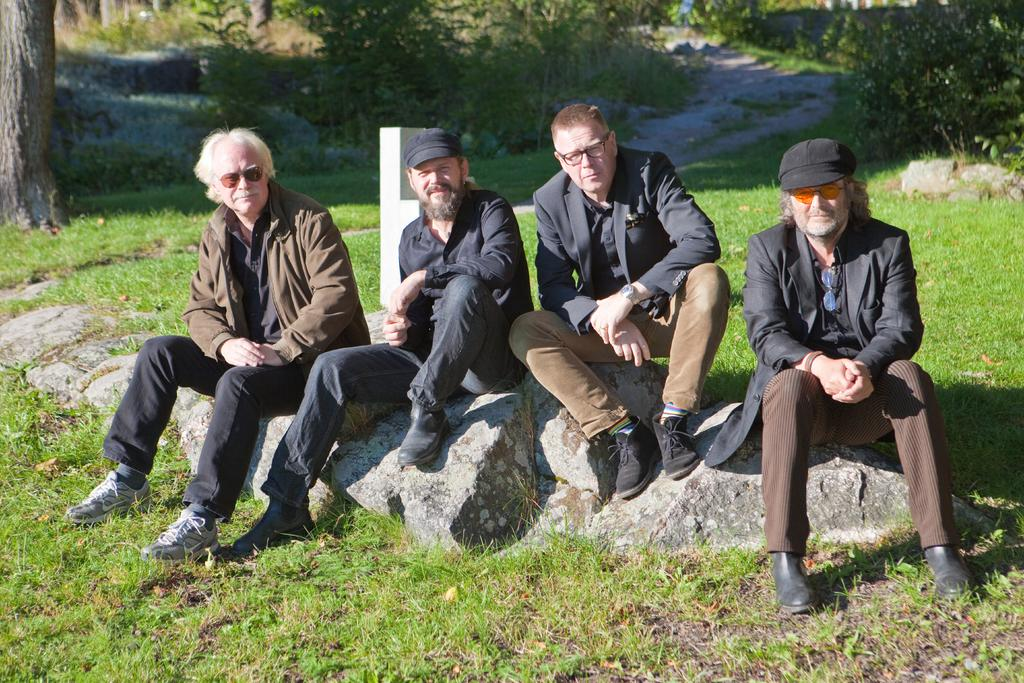What are the men in the image doing? The men are sitting on a rock in the image. What can be seen in the background of the image? There is a pole, grass, the bark of a tree, and a pathway visible in the image. What type of vegetation is present in the image? There is a group of plants in the image. How does the woman in the image express her regret? There is no woman present in the image, so it is not possible to answer that question. 